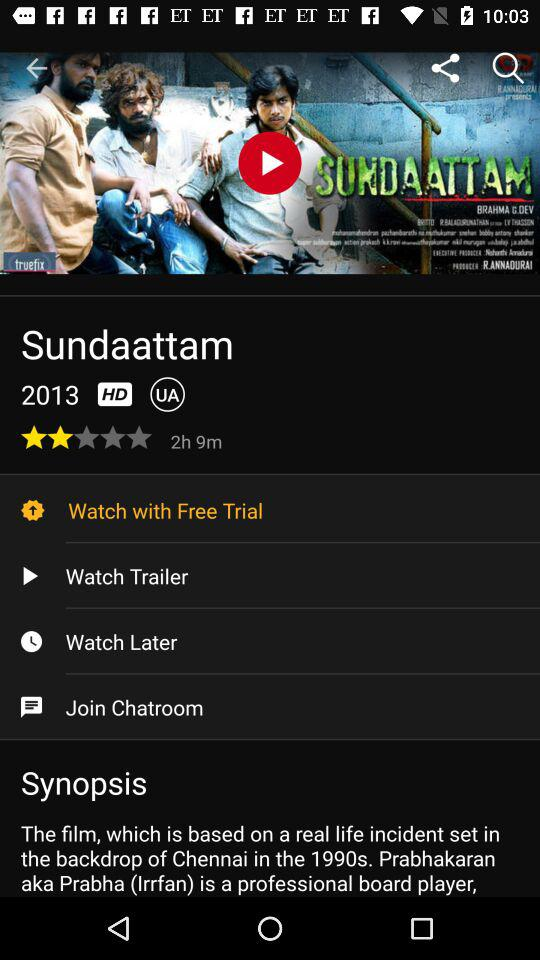How long is the trailer?
When the provided information is insufficient, respond with <no answer>. <no answer> 